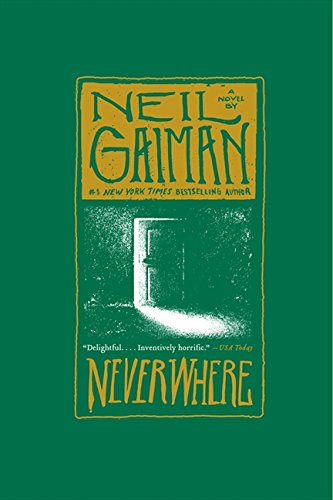How does Neil Gaiman's writing style contribute to the atmosphere of the novel? Neil Gaiman employs a lyrical, vivid prose that enhances the eerie and fantastical atmosphere of 'Neverwhere'. His ability to intertwine the ordinary with the extraordinary allows readers to plunge fully into the novel's richly crafted world. 